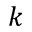Convert formula to latex. <formula><loc_0><loc_0><loc_500><loc_500>k</formula> 